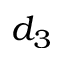Convert formula to latex. <formula><loc_0><loc_0><loc_500><loc_500>d _ { 3 }</formula> 